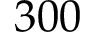Convert formula to latex. <formula><loc_0><loc_0><loc_500><loc_500>3 0 0</formula> 